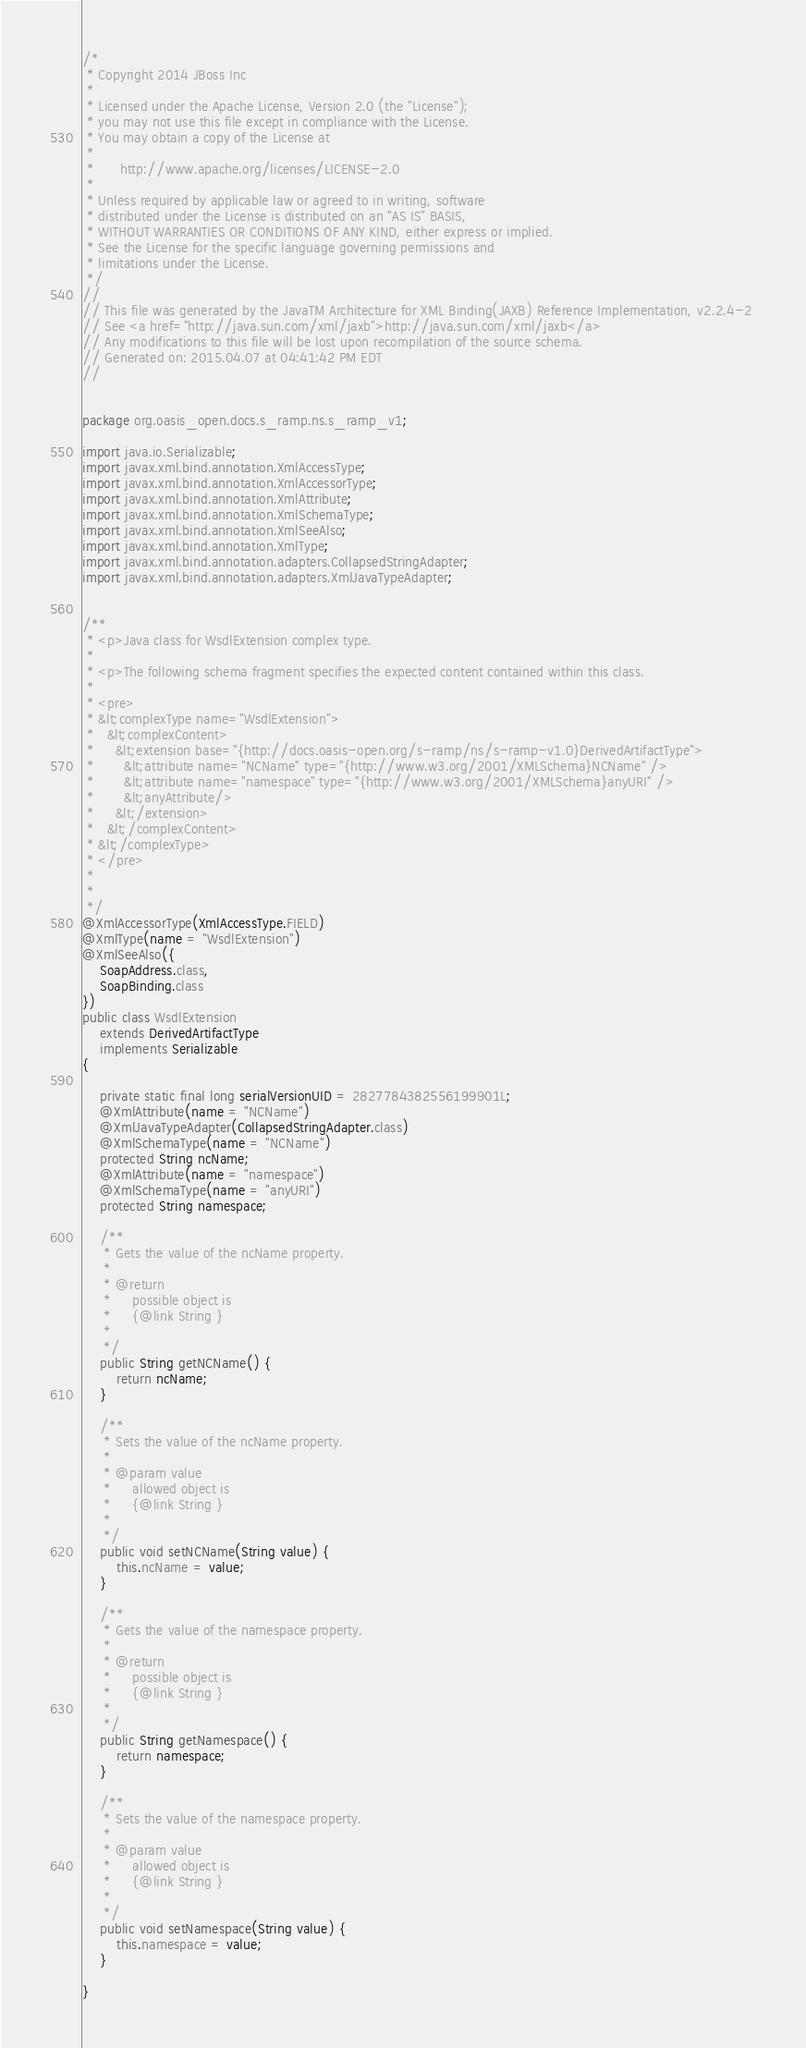Convert code to text. <code><loc_0><loc_0><loc_500><loc_500><_Java_>/*
 * Copyright 2014 JBoss Inc
 *
 * Licensed under the Apache License, Version 2.0 (the "License");
 * you may not use this file except in compliance with the License.
 * You may obtain a copy of the License at
 *
 *      http://www.apache.org/licenses/LICENSE-2.0
 *
 * Unless required by applicable law or agreed to in writing, software
 * distributed under the License is distributed on an "AS IS" BASIS,
 * WITHOUT WARRANTIES OR CONDITIONS OF ANY KIND, either express or implied.
 * See the License for the specific language governing permissions and
 * limitations under the License.
 */
//
// This file was generated by the JavaTM Architecture for XML Binding(JAXB) Reference Implementation, v2.2.4-2 
// See <a href="http://java.sun.com/xml/jaxb">http://java.sun.com/xml/jaxb</a> 
// Any modifications to this file will be lost upon recompilation of the source schema. 
// Generated on: 2015.04.07 at 04:41:42 PM EDT 
//


package org.oasis_open.docs.s_ramp.ns.s_ramp_v1;

import java.io.Serializable;
import javax.xml.bind.annotation.XmlAccessType;
import javax.xml.bind.annotation.XmlAccessorType;
import javax.xml.bind.annotation.XmlAttribute;
import javax.xml.bind.annotation.XmlSchemaType;
import javax.xml.bind.annotation.XmlSeeAlso;
import javax.xml.bind.annotation.XmlType;
import javax.xml.bind.annotation.adapters.CollapsedStringAdapter;
import javax.xml.bind.annotation.adapters.XmlJavaTypeAdapter;


/**
 * <p>Java class for WsdlExtension complex type.
 * 
 * <p>The following schema fragment specifies the expected content contained within this class.
 * 
 * <pre>
 * &lt;complexType name="WsdlExtension">
 *   &lt;complexContent>
 *     &lt;extension base="{http://docs.oasis-open.org/s-ramp/ns/s-ramp-v1.0}DerivedArtifactType">
 *       &lt;attribute name="NCName" type="{http://www.w3.org/2001/XMLSchema}NCName" />
 *       &lt;attribute name="namespace" type="{http://www.w3.org/2001/XMLSchema}anyURI" />
 *       &lt;anyAttribute/>
 *     &lt;/extension>
 *   &lt;/complexContent>
 * &lt;/complexType>
 * </pre>
 * 
 * 
 */
@XmlAccessorType(XmlAccessType.FIELD)
@XmlType(name = "WsdlExtension")
@XmlSeeAlso({
    SoapAddress.class,
    SoapBinding.class
})
public class WsdlExtension
    extends DerivedArtifactType
    implements Serializable
{

    private static final long serialVersionUID = 2827784382556199901L;
    @XmlAttribute(name = "NCName")
    @XmlJavaTypeAdapter(CollapsedStringAdapter.class)
    @XmlSchemaType(name = "NCName")
    protected String ncName;
    @XmlAttribute(name = "namespace")
    @XmlSchemaType(name = "anyURI")
    protected String namespace;

    /**
     * Gets the value of the ncName property.
     * 
     * @return
     *     possible object is
     *     {@link String }
     *     
     */
    public String getNCName() {
        return ncName;
    }

    /**
     * Sets the value of the ncName property.
     * 
     * @param value
     *     allowed object is
     *     {@link String }
     *     
     */
    public void setNCName(String value) {
        this.ncName = value;
    }

    /**
     * Gets the value of the namespace property.
     * 
     * @return
     *     possible object is
     *     {@link String }
     *     
     */
    public String getNamespace() {
        return namespace;
    }

    /**
     * Sets the value of the namespace property.
     * 
     * @param value
     *     allowed object is
     *     {@link String }
     *     
     */
    public void setNamespace(String value) {
        this.namespace = value;
    }

}
</code> 